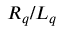Convert formula to latex. <formula><loc_0><loc_0><loc_500><loc_500>R _ { q } / L _ { q }</formula> 